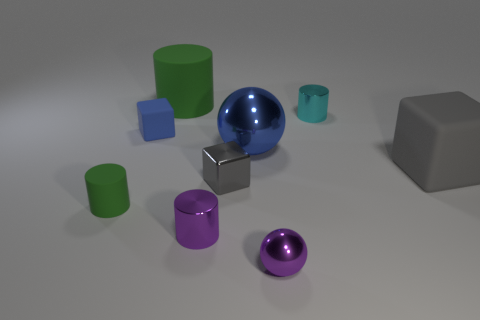Subtract all gray cylinders. Subtract all red blocks. How many cylinders are left? 4 Subtract all spheres. How many objects are left? 7 Subtract 1 blue spheres. How many objects are left? 8 Subtract all tiny purple spheres. Subtract all tiny gray metallic objects. How many objects are left? 7 Add 6 small gray things. How many small gray things are left? 7 Add 4 blue things. How many blue things exist? 6 